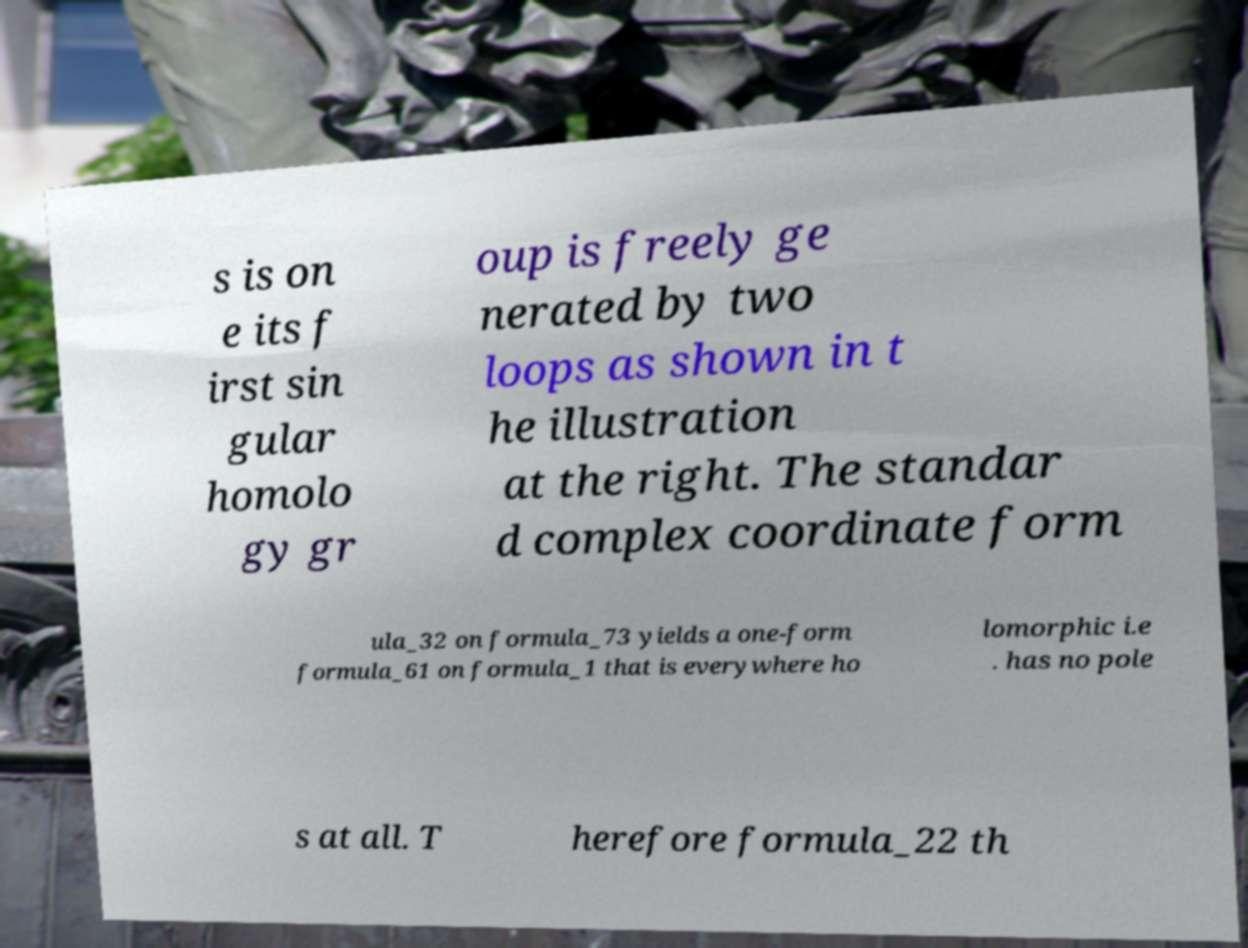Please identify and transcribe the text found in this image. s is on e its f irst sin gular homolo gy gr oup is freely ge nerated by two loops as shown in t he illustration at the right. The standar d complex coordinate form ula_32 on formula_73 yields a one-form formula_61 on formula_1 that is everywhere ho lomorphic i.e . has no pole s at all. T herefore formula_22 th 